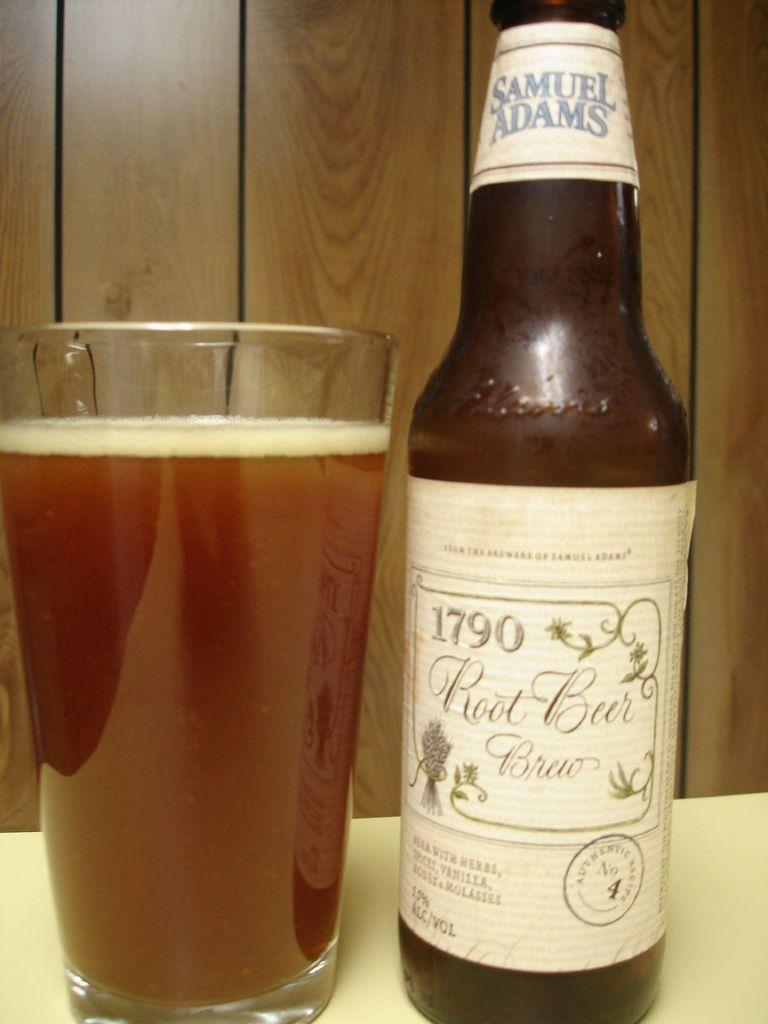<image>
Summarize the visual content of the image. A full glass of beer next to a bottle of Samuel Adams Root Beer brew. 